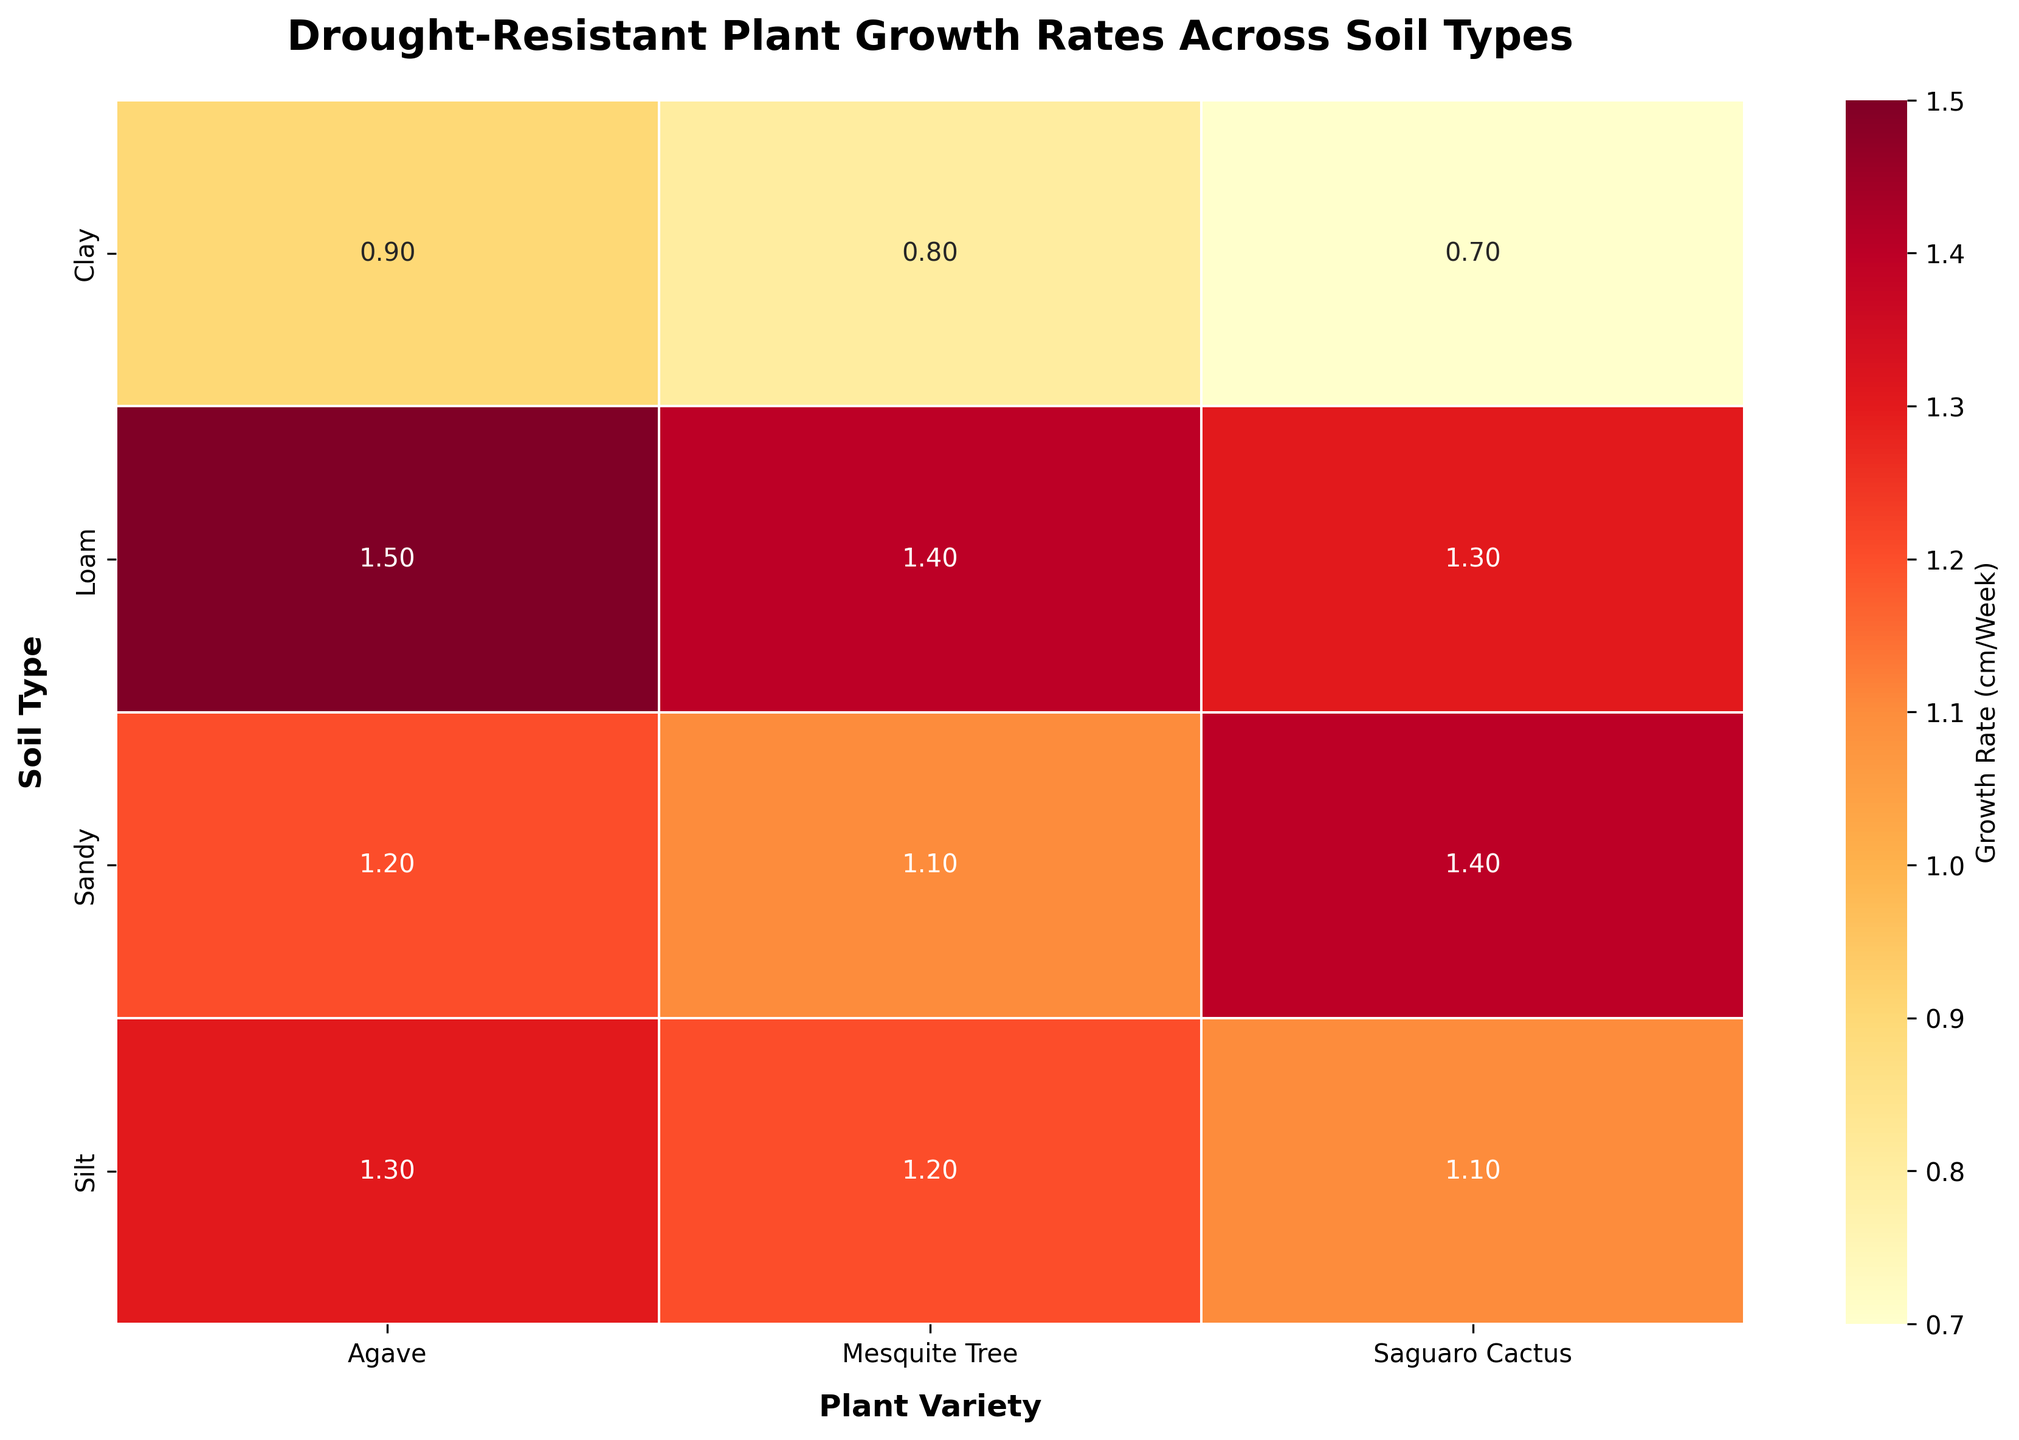What is the title of the heatmap? The title is usually found at the top of the heatmap and provides a brief description of what the plot is about.
Answer: Drought-Resistant Plant Growth Rates Across Soil Types Which plant variety has the highest growth rate in sandy soil? Look for the cell in the "Sandy" row with the highest numerical value and check its corresponding column header.
Answer: Saguaro Cactus How does the growth rate of Agave in clay soil compare to that in loam soil? Find the growth rates for Agave in both "Clay" and "Loam" rows, and compare the values by subtraction.
Answer: Loam soil is 0.6 cm/week higher What soil type has the highest overall growth rate for Mesquite Tree? Check the growth rates for Mesquite Tree across all soil types, and identify the highest value along with its corresponding row label.
Answer: Loam What is the average growth rate for Saguaro Cactus across all soil types? Sum the growth rates of Saguaro Cactus across all soil types and divide by the number of soil types (4).
Answer: 1.125 cm/week Which plant variety has the most consistent growth rate across different soil types? Calculate the range (maximum minus minimum) for each plant variety's growth rates across all soil types, and find the one with the smallest range.
Answer: Saguaro Cactus In which soil type do all plant varieties have growth rates above 1 cm/week? Inspect each row and check if all growth rates exceed 1 cm/week.
Answer: Sandy Which combination of soil type and plant variety yields the lowest growth rate? Find the cell with the lowest value in the entire heatmap and note its row (soil type) and column (plant variety).
Answer: Saguaro Cactus in Clay Between loam and silt soils, which one shows better growth rates for Mesquite Tree and Saguaro Cactus? Compare the growth rates of Mesquite Tree and Saguaro Cactus in "Loam" and "Silt" rows. Add the growth rates for both plants in each soil type and compare the sums.
Answer: Loam Is there any soil type where the growth rate order among plant varieties is the same? For each soil type, check if the order of growth rates among the three plant varieties is identical, then verify if this is consistent for a given soil type across others.
Answer: No 